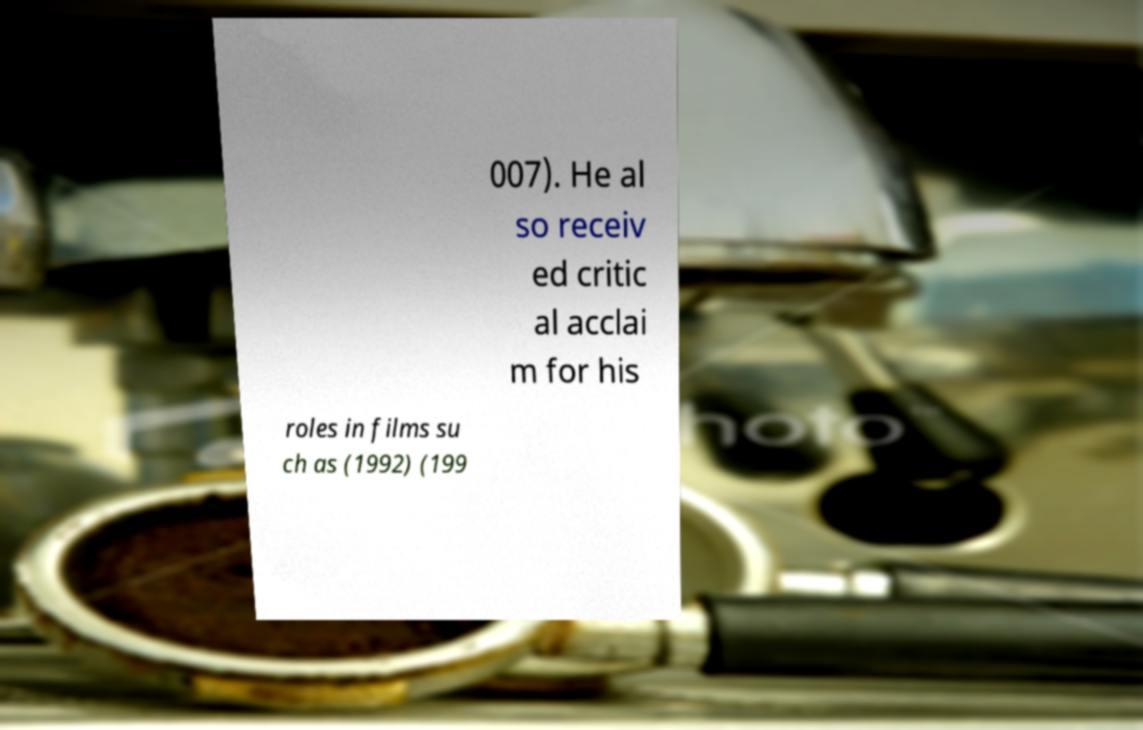Can you accurately transcribe the text from the provided image for me? 007). He al so receiv ed critic al acclai m for his roles in films su ch as (1992) (199 